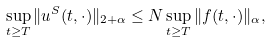Convert formula to latex. <formula><loc_0><loc_0><loc_500><loc_500>\sup _ { t \geq T } \| u ^ { S } ( t , \cdot ) \| _ { 2 + \alpha } \leq N \sup _ { t \geq T } \| f ( t , \cdot ) \| _ { \alpha } ,</formula> 